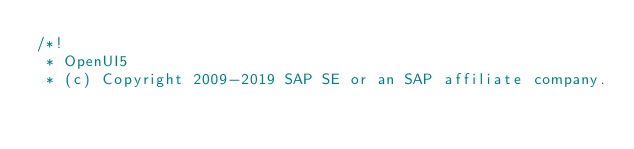<code> <loc_0><loc_0><loc_500><loc_500><_JavaScript_>/*!
 * OpenUI5
 * (c) Copyright 2009-2019 SAP SE or an SAP affiliate company.</code> 